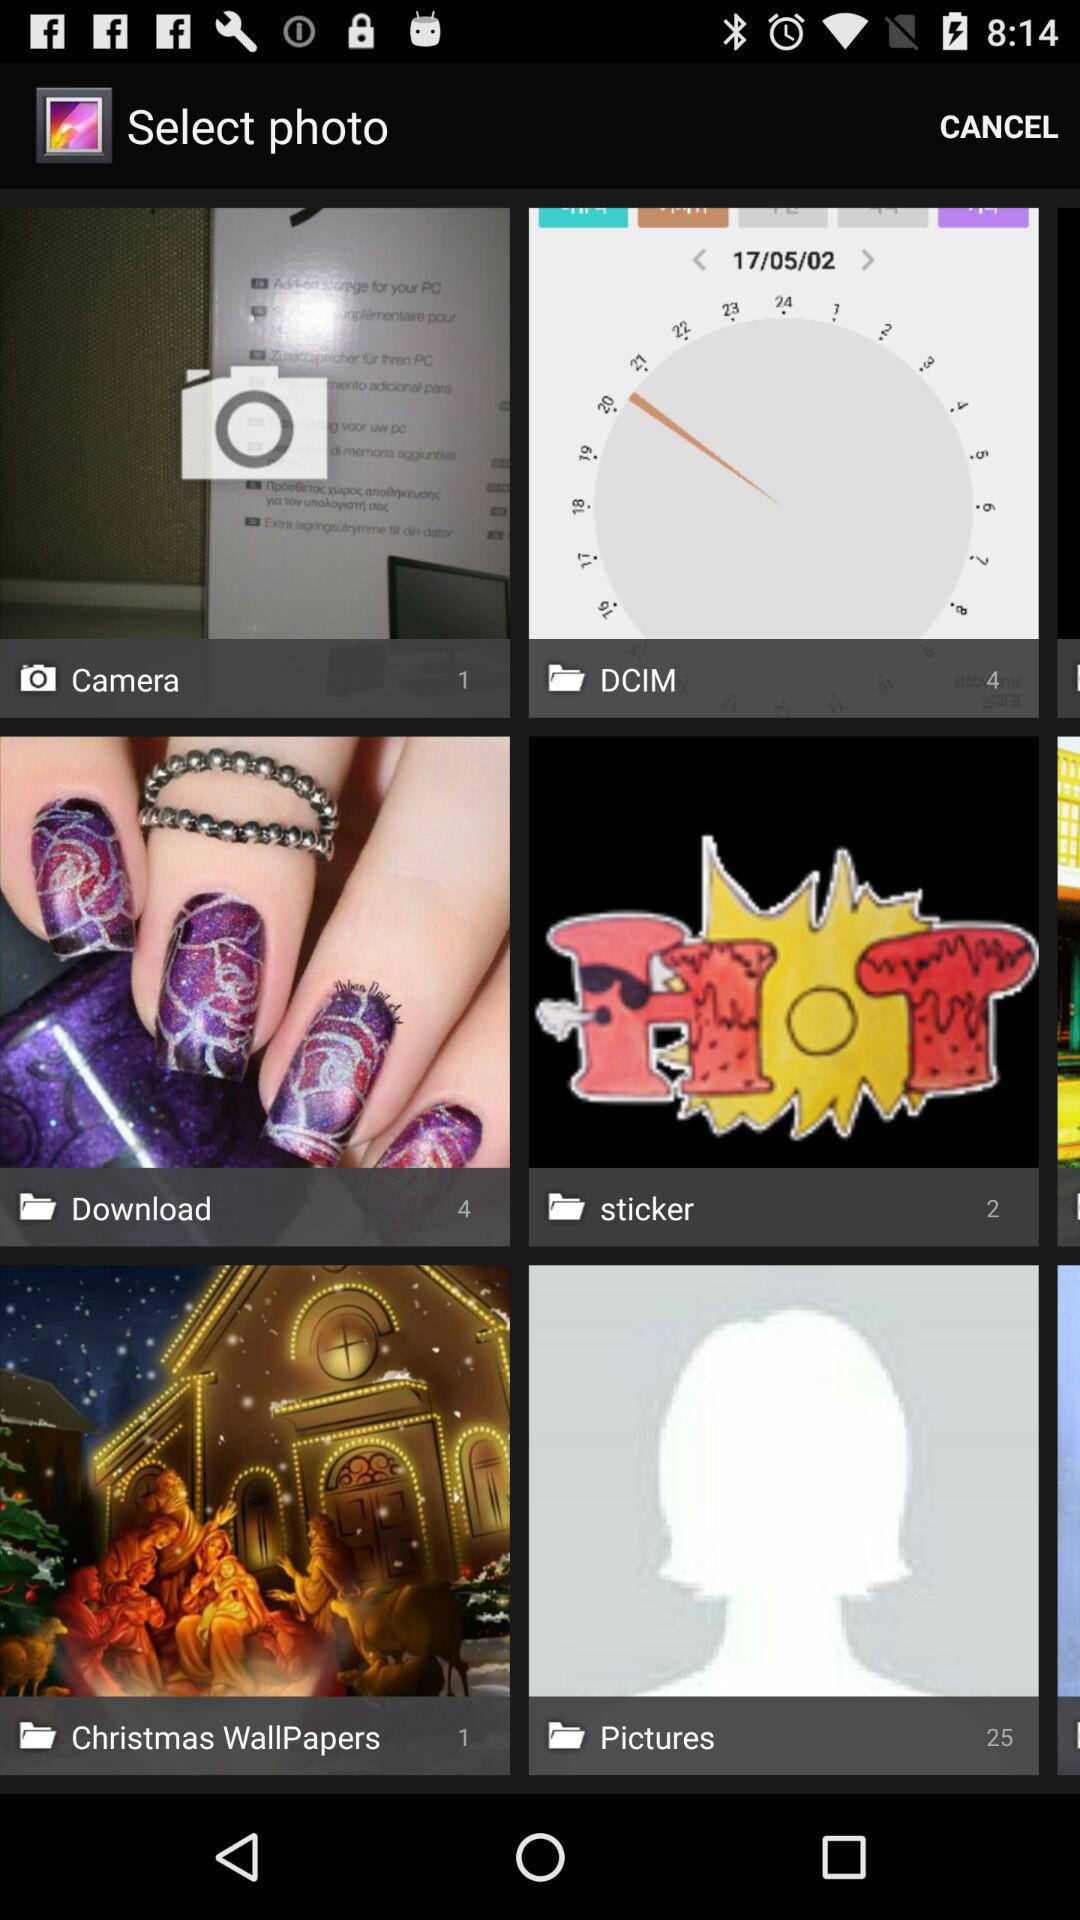What is the number of photos in "sticker"? The number of photos is 2. 